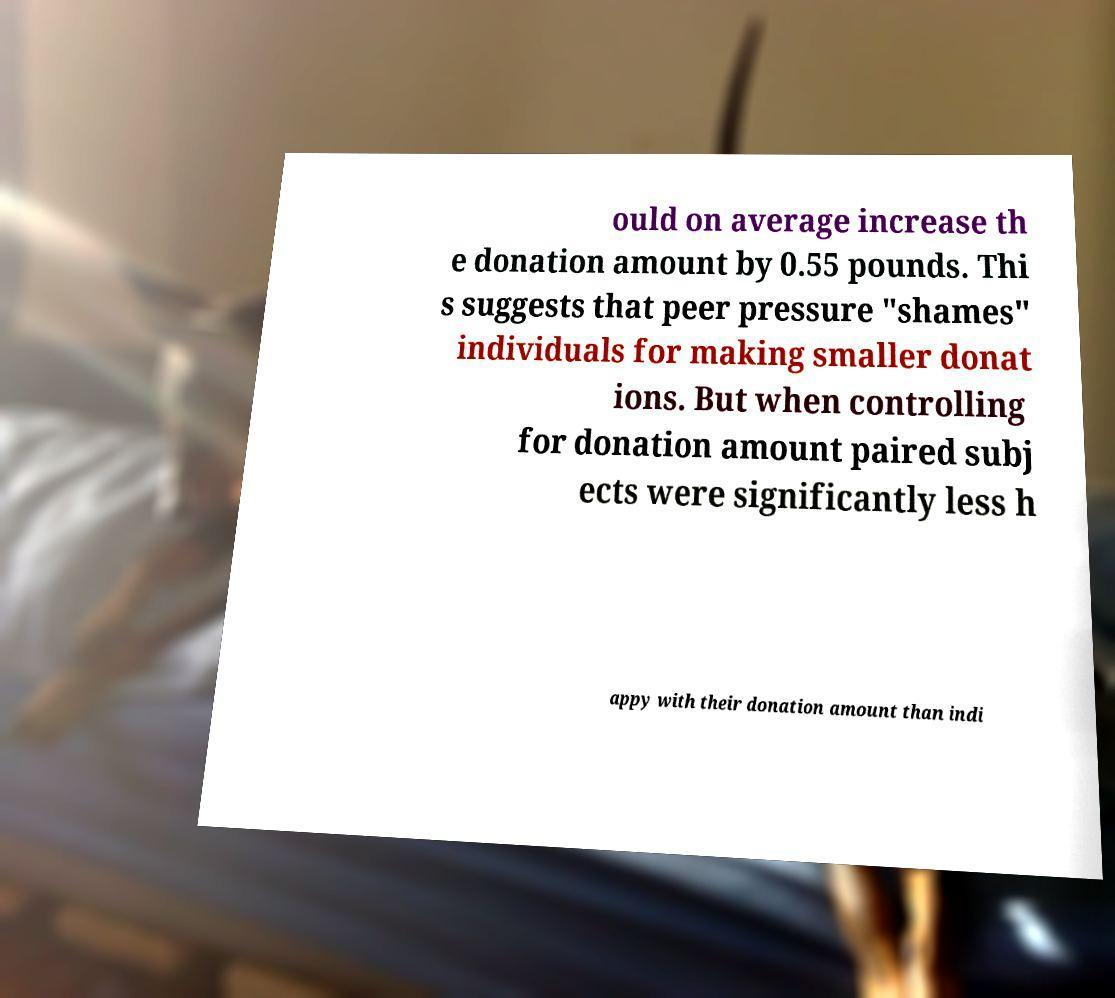There's text embedded in this image that I need extracted. Can you transcribe it verbatim? ould on average increase th e donation amount by 0.55 pounds. Thi s suggests that peer pressure "shames" individuals for making smaller donat ions. But when controlling for donation amount paired subj ects were significantly less h appy with their donation amount than indi 